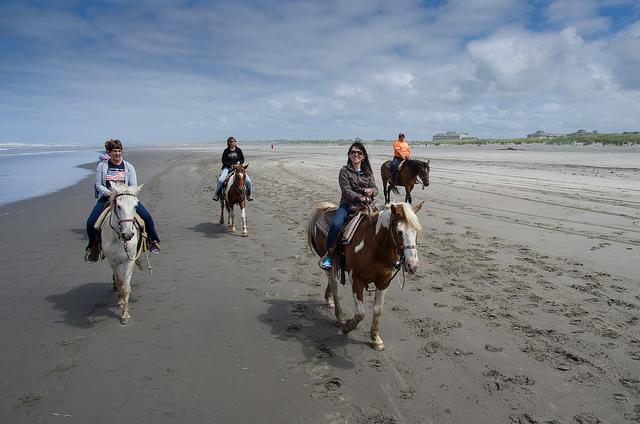Are the horses all the same color?
Write a very short answer. No. What kind of horse is the girl riding on?
Answer briefly. Pony. Are the horses a male or female?
Short answer required. Male. Where was this photo taken?
Write a very short answer. Beach. Is the sky cloudless?
Short answer required. No. How many animals are shown?
Concise answer only. 4. 